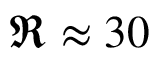<formula> <loc_0><loc_0><loc_500><loc_500>\Re \approx 3 0</formula> 